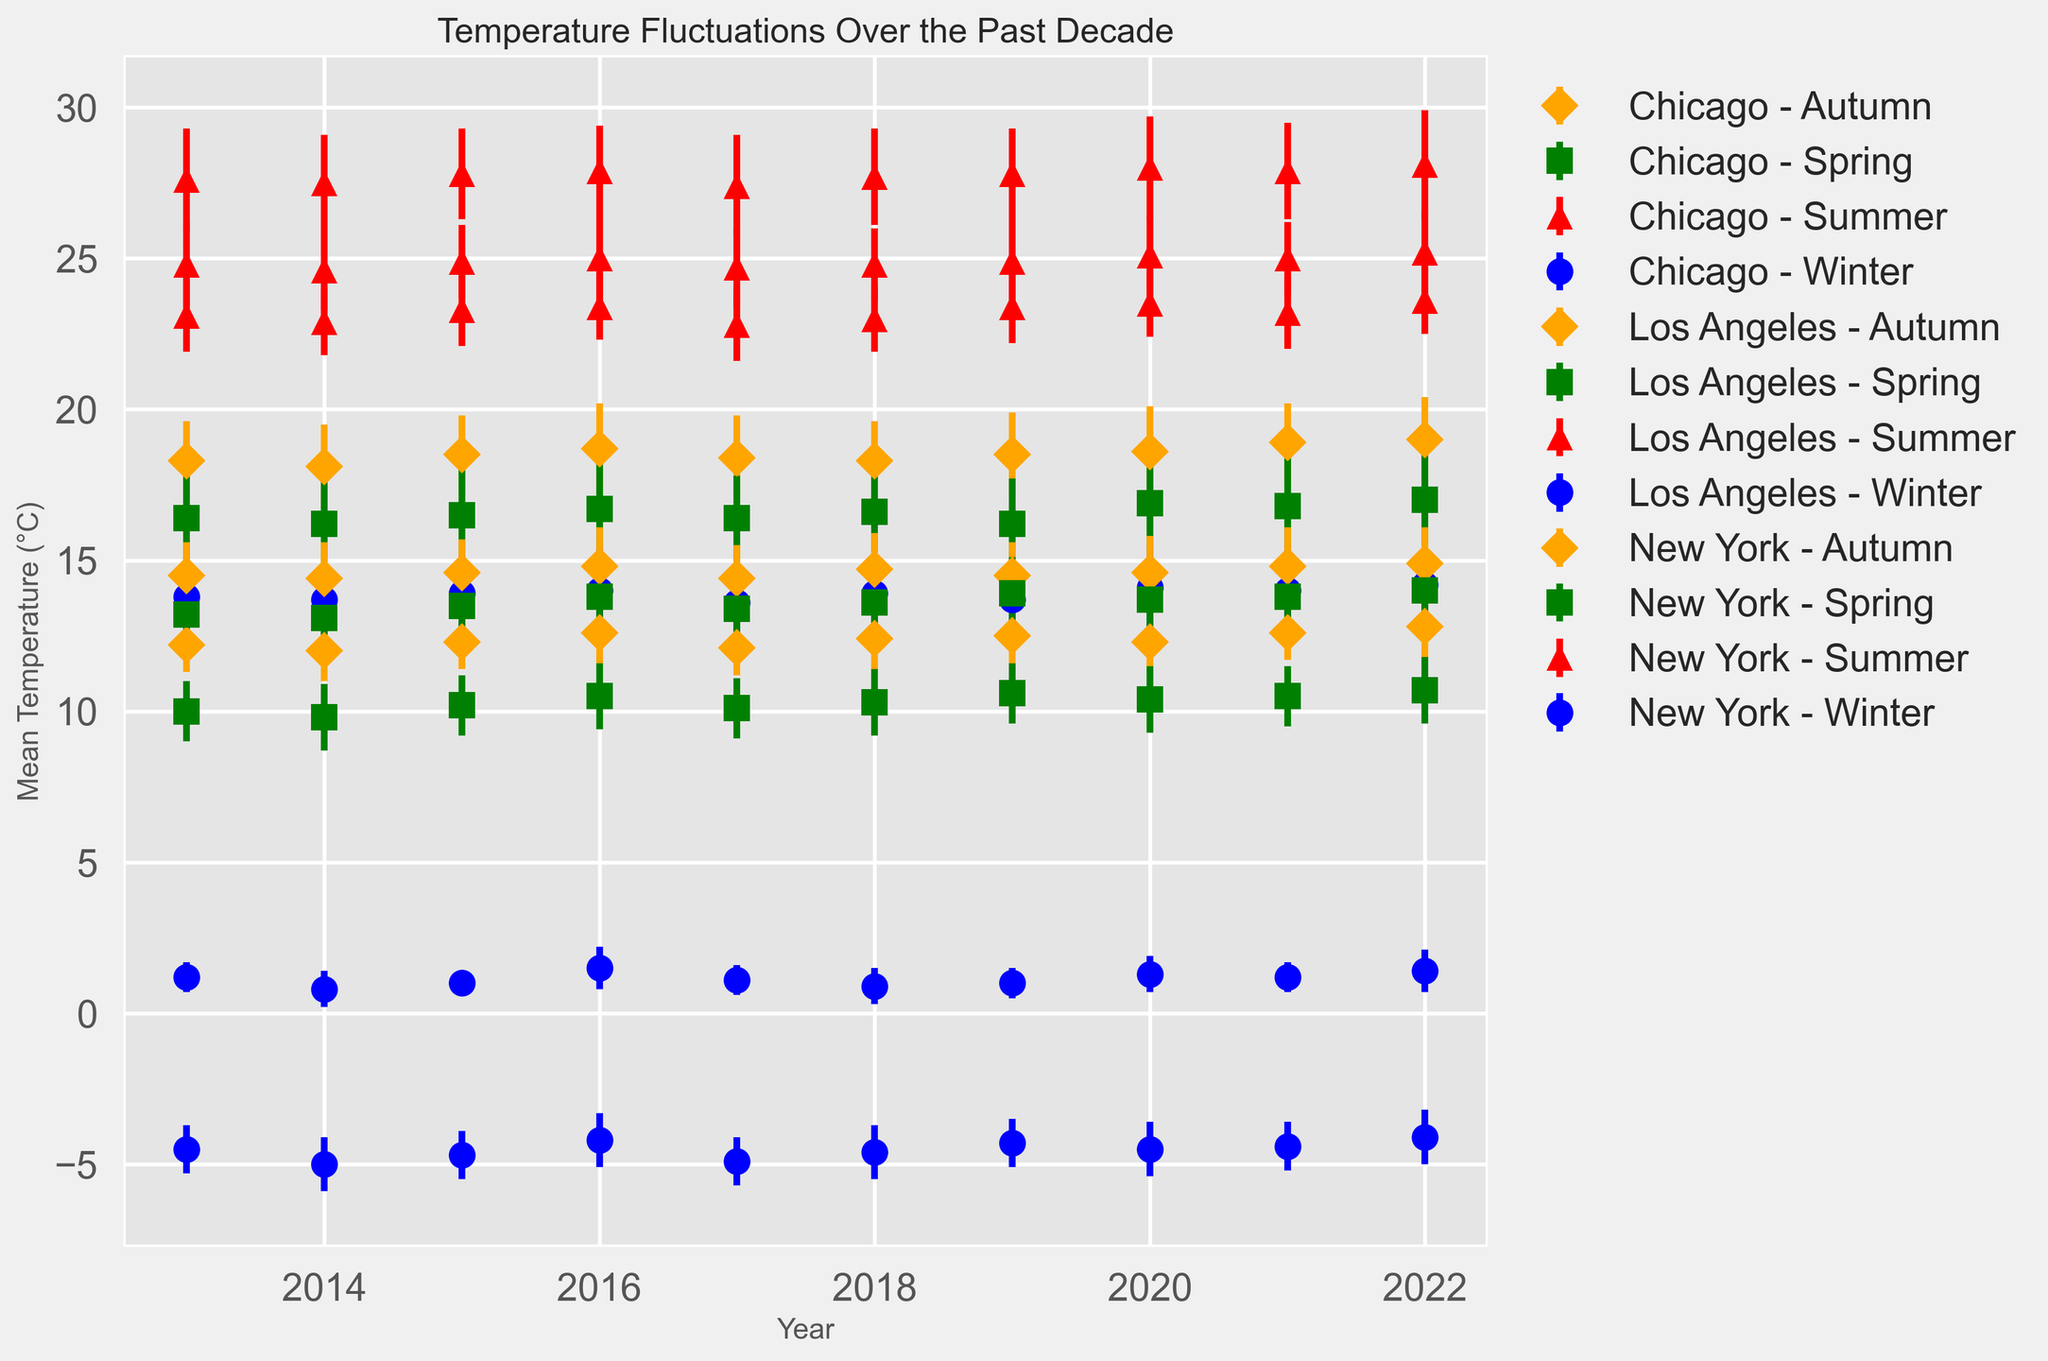What's the average summer temperature in Los Angeles over the past decade? To calculate the average, sum up all the mean summer temperatures for Los Angeles from 2013 to 2022 and divide by the number of years which is 10. The temperatures are 27.6, 27.5, 27.8, 27.9, 27.4, 27.7, 27.8, 28.0, 27.9, 28.1. The sum is 276.7, and the average is 276.7/10 = 27.67
Answer: 27.67 Which city had the highest mean temperature in winter 2022? Analyze the winter data points for all three cities in 2022. New York had 1.4°C, Los Angeles had 14.2°C, and Chicago had -4.1°C. The highest temperature was recorded in Los Angeles.
Answer: Los Angeles In which year did New York experience the highest spring temperature and what was it? Compare the spring temperatures in New York from 2013 to 2022. The highest temperature is seen in the year 2022, with 14.0°C.
Answer: 2022, 14.0°C How does the standard deviation of summer temperatures in New York compare to Chicago in 2022? Look at the summer data for 2022 for both cities. New York's standard deviation is 1.4 while Chicago's is 1.1. New York has a higher standard deviation than Chicago in 2022.
Answer: New York has a higher standard deviation What is the trend in autumn temperatures in Los Angeles over the past decade? Observe the autumn temperature plot for Los Angeles from 2013 to 2022. The trend shows a gradual increase from 18.3°C in 2013 to 19.0°C in 2022. The overall trend is an increase.
Answer: Increasing trend Which season in Chicago has the smallest mean temperature variation across the years? Assess the standard deviations for each season in Chicago. Smaller standard deviations indicate smaller variations. The winter standard deviations are around 0.8-0.9, spring about 1.0-1.1, summer 1.1-1.2, and autumn 0.9-1.0. Winter has the smallest variation.
Answer: Winter Between New York, Los Angeles, and Chicago, which city showed the highest variability in winter temperatures in 2020? Compare the standard deviations for winter temperatures in New York, Los Angeles, and Chicago in 2020. New York had 0.6, Los Angeles had 1.4, and Chicago had 0.9. Los Angeles showed the highest variability.
Answer: Los Angeles What was the difference in mean summer temperatures between Chicago and Los Angeles in 2016? Subtract the mean summer temperature of Chicago from that of Los Angeles in 2016. Chicago's was 23.4°C and Los Angeles's was 27.9°C. The difference is 27.9 - 23.4 = 4.5°C.
Answer: 4.5°C Which city experienced the least change in mean temperature from summer to autumn in 2022? Subtract the mean autumn temperature from the mean summer temperature for each city in 2022. New York: 25.2 - 14.9 = 10.3°C, Los Angeles: 28.1 - 19.0 = 9.1°C, Chicago: 23.6 - 12.8 = 10.8°C. Los Angeles experienced the least change.
Answer: Los Angeles What was the mean winter temperature in New York in 2018 and how does it compare to 2016? Take the winter data points for New York in 2018 and 2016. In 2018, the temperature was 0.9°C, and in 2016, it was 1.5°C. The temperature in 2018 was 0.6°C lower than in 2016.
Answer: 0.9°C, 0.6°C lower 